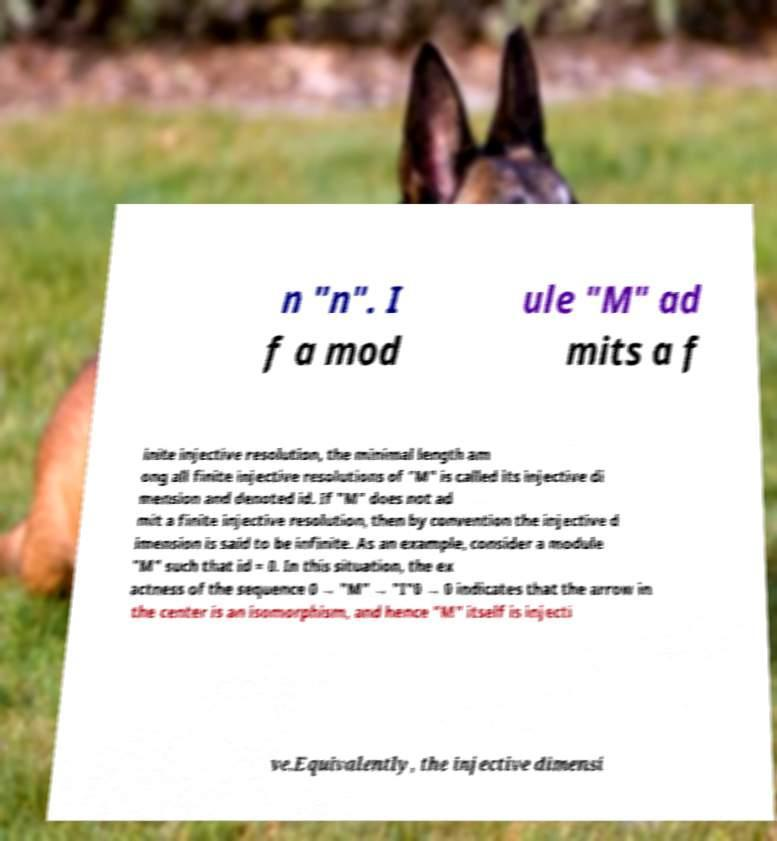There's text embedded in this image that I need extracted. Can you transcribe it verbatim? n "n". I f a mod ule "M" ad mits a f inite injective resolution, the minimal length am ong all finite injective resolutions of "M" is called its injective di mension and denoted id. If "M" does not ad mit a finite injective resolution, then by convention the injective d imension is said to be infinite. As an example, consider a module "M" such that id = 0. In this situation, the ex actness of the sequence 0 → "M" → "I"0 → 0 indicates that the arrow in the center is an isomorphism, and hence "M" itself is injecti ve.Equivalently, the injective dimensi 